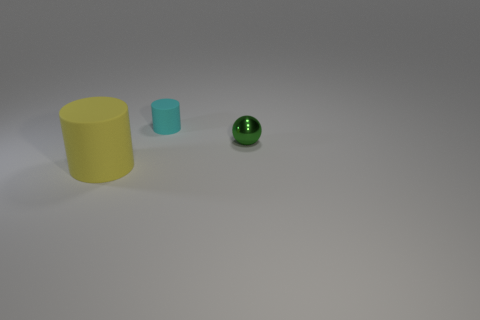There is another cyan object that is the same shape as the big thing; what is it made of?
Your response must be concise. Rubber. Are there any other things that have the same size as the yellow rubber cylinder?
Offer a terse response. No. There is a matte thing that is on the right side of the matte object that is in front of the metallic sphere; what size is it?
Your answer should be compact. Small. What is the color of the metal thing?
Your answer should be very brief. Green. There is a small object that is in front of the tiny cyan matte cylinder; how many balls are behind it?
Make the answer very short. 0. There is a rubber cylinder behind the small green shiny sphere; are there any cyan cylinders that are in front of it?
Provide a succinct answer. No. Are there any yellow matte things behind the big yellow thing?
Your response must be concise. No. There is a rubber object behind the large yellow rubber cylinder; is its shape the same as the large yellow thing?
Provide a short and direct response. Yes. How many other objects are the same shape as the small cyan matte thing?
Your response must be concise. 1. Is there a big yellow cylinder that has the same material as the tiny cyan object?
Give a very brief answer. Yes. 